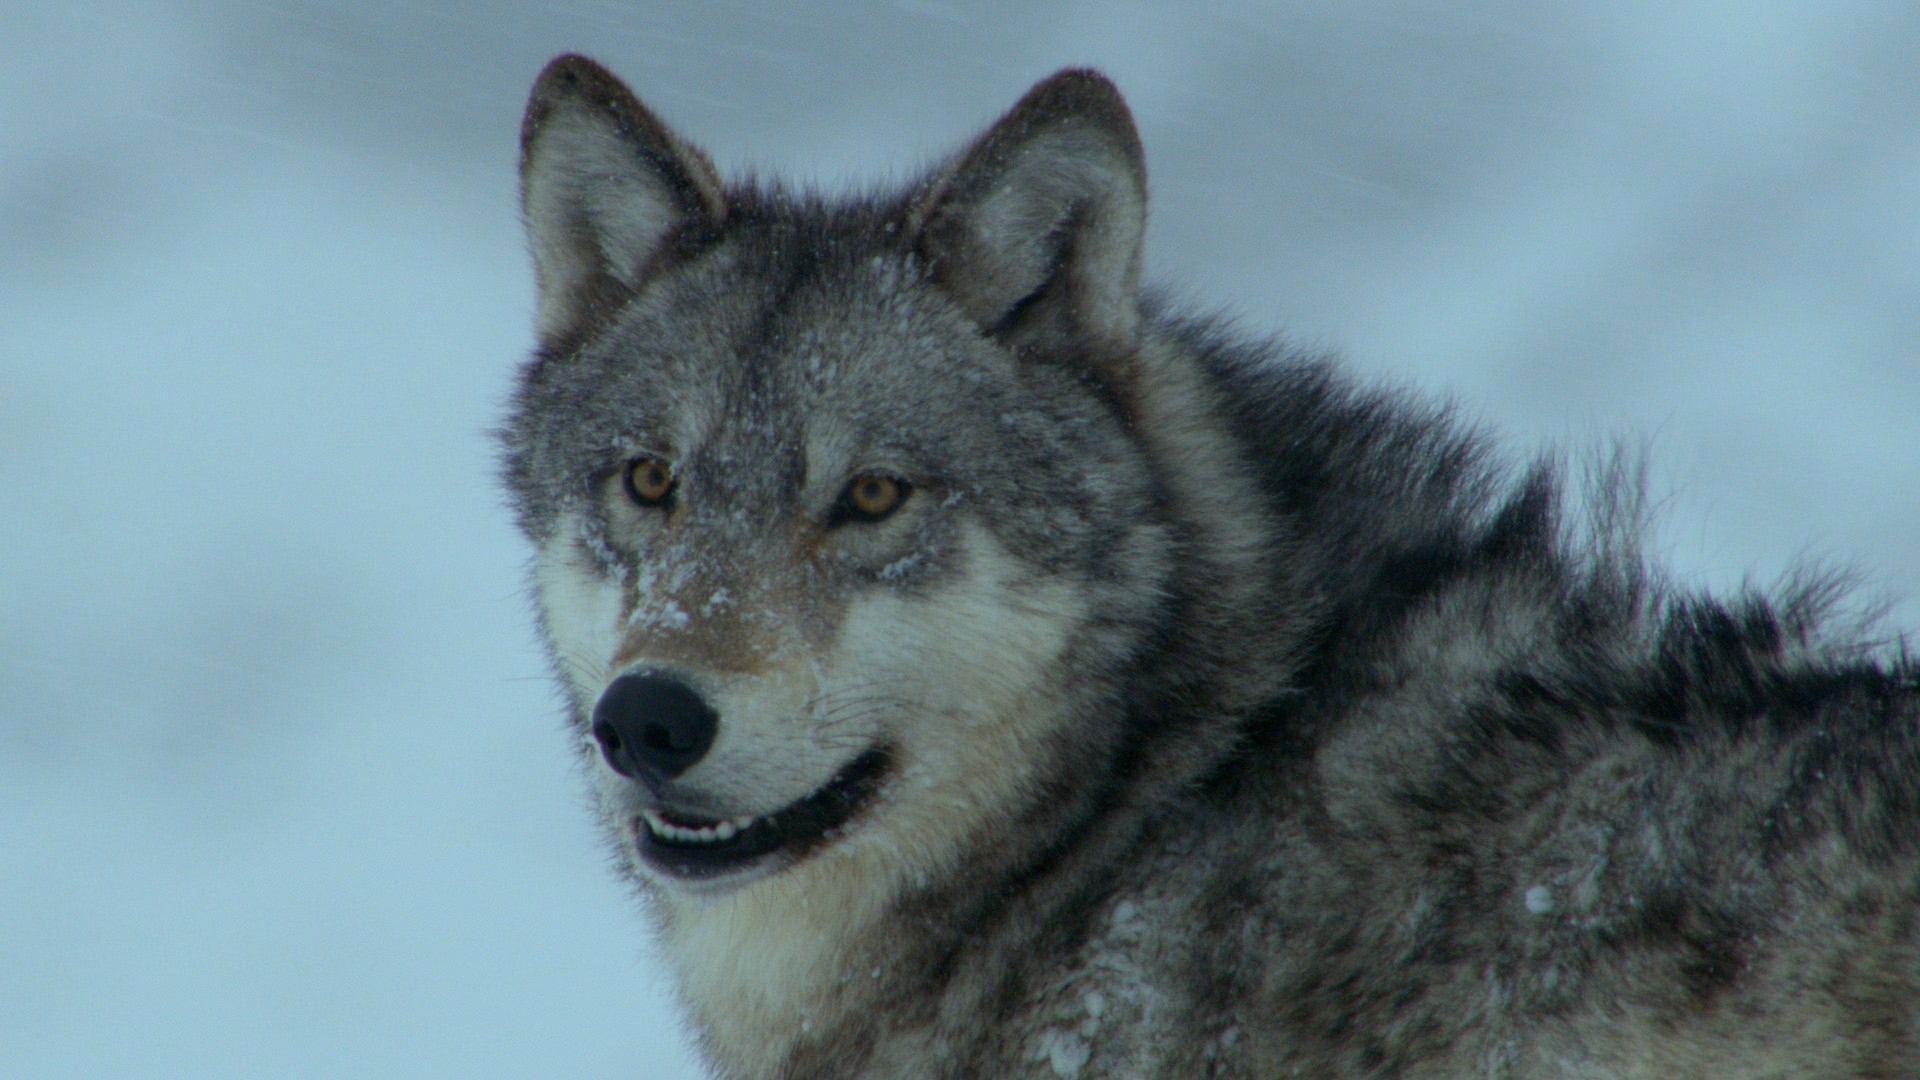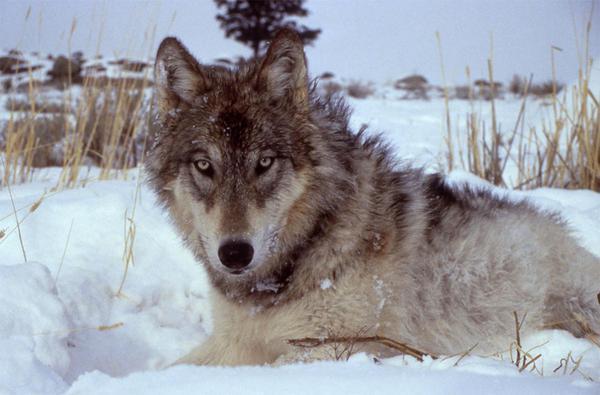The first image is the image on the left, the second image is the image on the right. Assess this claim about the two images: "The left image contains at least two wolves.". Correct or not? Answer yes or no. No. The first image is the image on the left, the second image is the image on the right. For the images displayed, is the sentence "There are exactly two wolves in total." factually correct? Answer yes or no. Yes. 